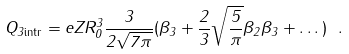<formula> <loc_0><loc_0><loc_500><loc_500>Q _ { 3 \text {intr} } = e Z R _ { 0 } ^ { 3 } \frac { 3 } { 2 \sqrt { 7 \pi } } ( \beta _ { 3 } + \frac { 2 } { 3 } \sqrt { \frac { 5 } { \pi } } \beta _ { 2 } \beta _ { 3 } + \dots ) \ .</formula> 